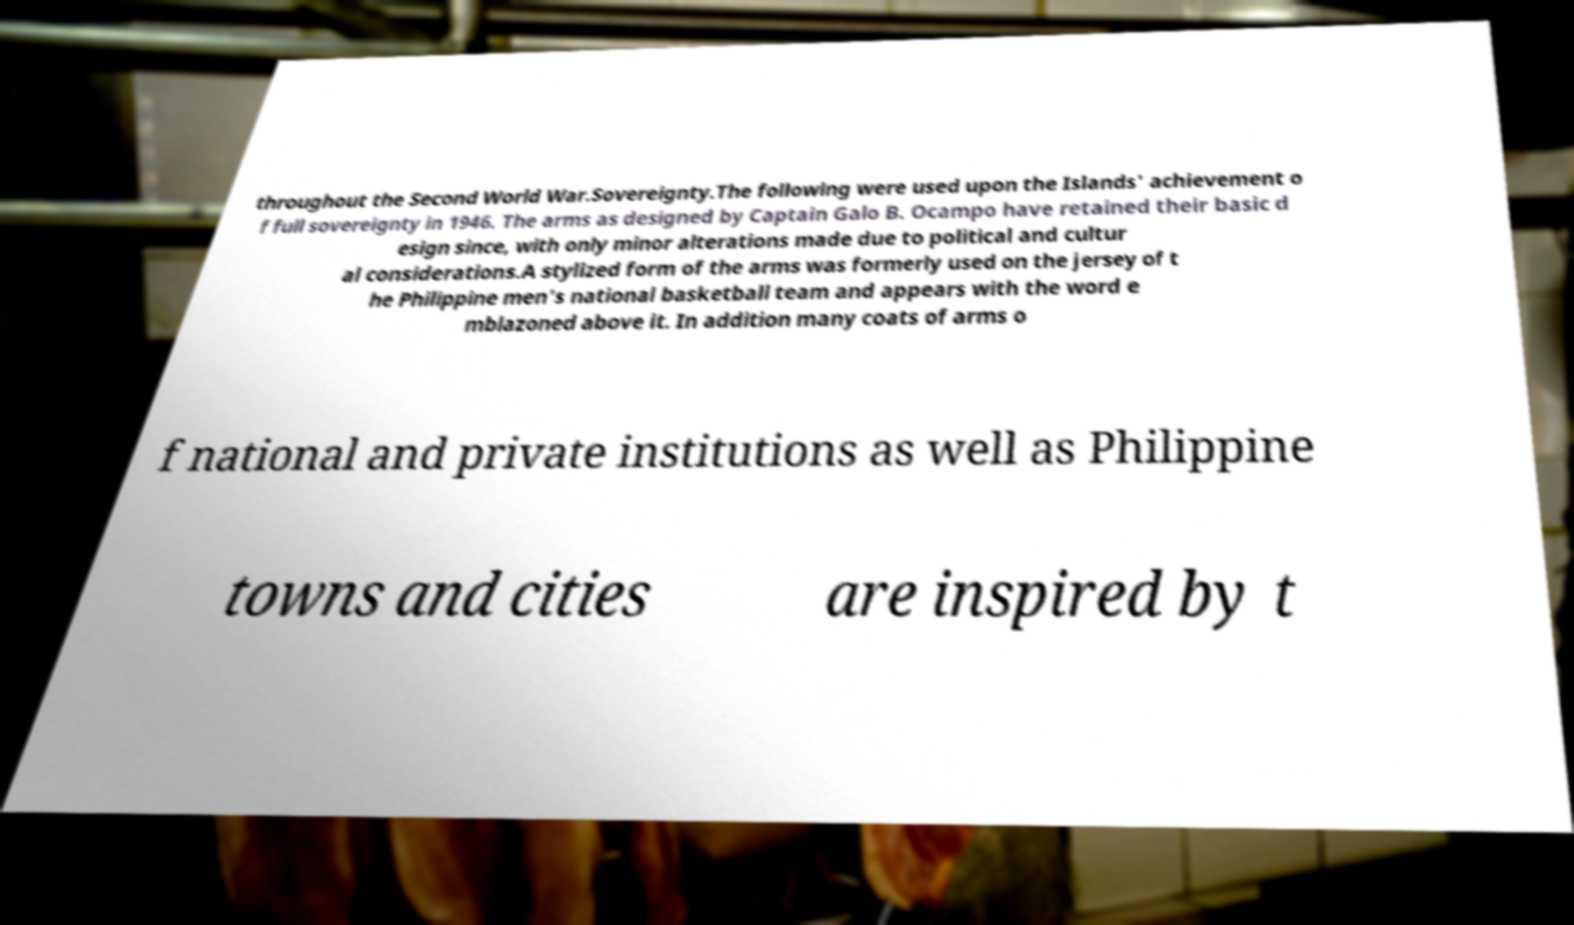There's text embedded in this image that I need extracted. Can you transcribe it verbatim? throughout the Second World War.Sovereignty.The following were used upon the Islands' achievement o f full sovereignty in 1946. The arms as designed by Captain Galo B. Ocampo have retained their basic d esign since, with only minor alterations made due to political and cultur al considerations.A stylized form of the arms was formerly used on the jersey of t he Philippine men's national basketball team and appears with the word e mblazoned above it. In addition many coats of arms o f national and private institutions as well as Philippine towns and cities are inspired by t 